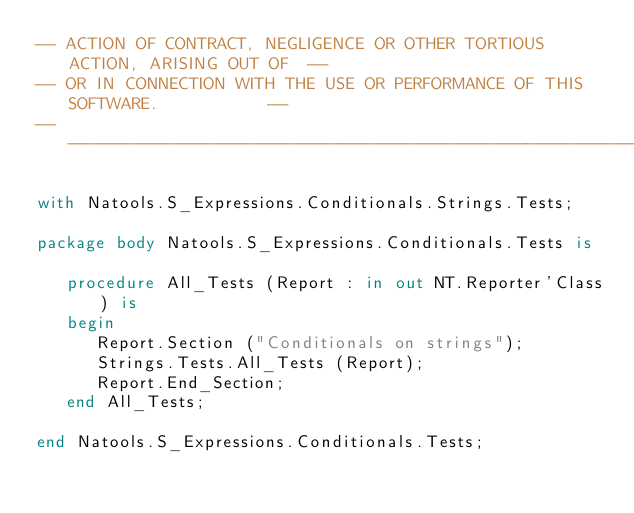<code> <loc_0><loc_0><loc_500><loc_500><_Ada_>-- ACTION OF CONTRACT, NEGLIGENCE OR OTHER TORTIOUS ACTION, ARISING OUT OF  --
-- OR IN CONNECTION WITH THE USE OR PERFORMANCE OF THIS SOFTWARE.           --
------------------------------------------------------------------------------

with Natools.S_Expressions.Conditionals.Strings.Tests;

package body Natools.S_Expressions.Conditionals.Tests is

   procedure All_Tests (Report : in out NT.Reporter'Class) is
   begin
      Report.Section ("Conditionals on strings");
      Strings.Tests.All_Tests (Report);
      Report.End_Section;
   end All_Tests;

end Natools.S_Expressions.Conditionals.Tests;
</code> 